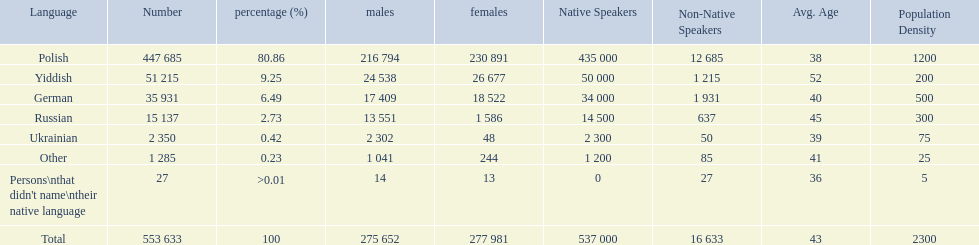What language makes a majority Polish. What the the total number of speakers? 553 633. 